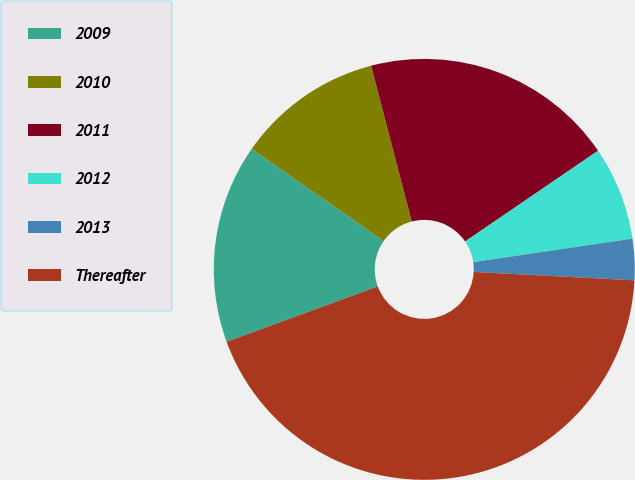Convert chart to OTSL. <chart><loc_0><loc_0><loc_500><loc_500><pie_chart><fcel>2009<fcel>2010<fcel>2011<fcel>2012<fcel>2013<fcel>Thereafter<nl><fcel>15.29%<fcel>11.24%<fcel>19.53%<fcel>7.2%<fcel>3.16%<fcel>43.58%<nl></chart> 